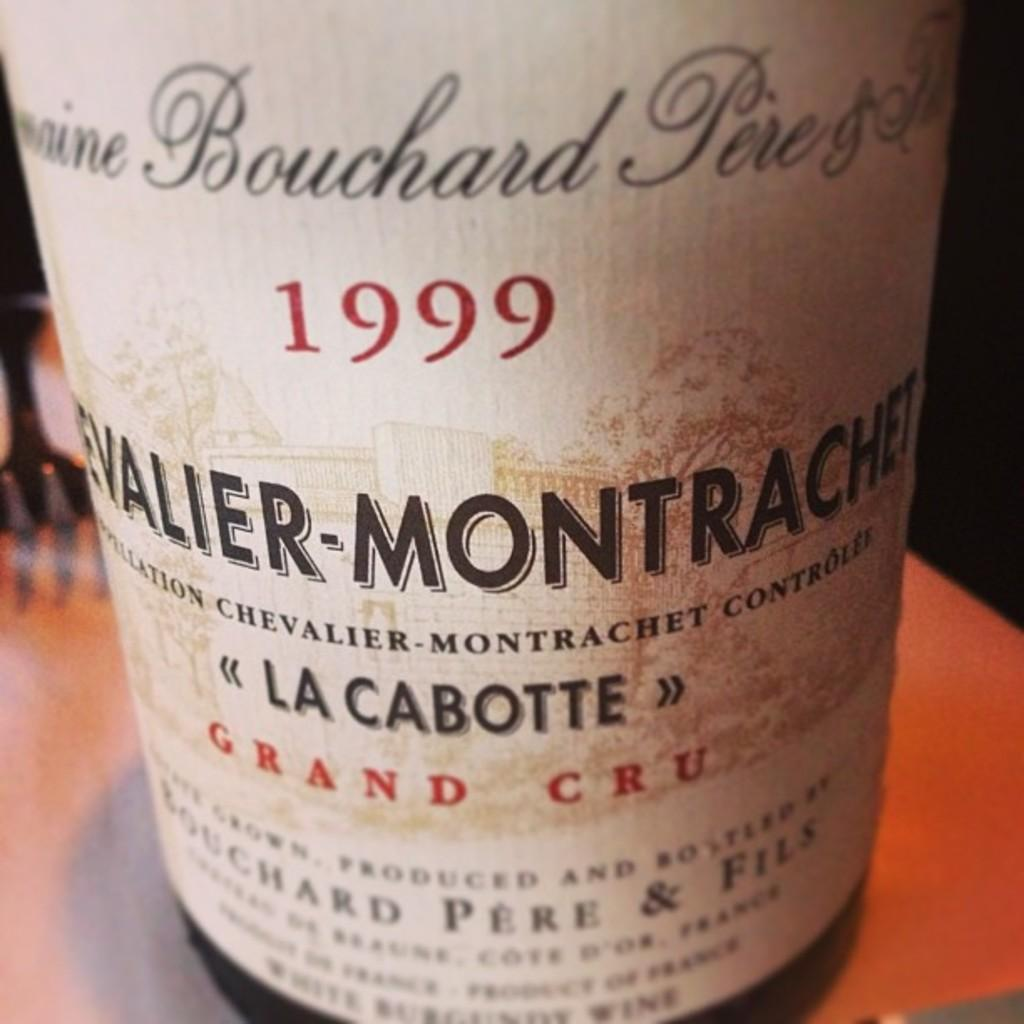<image>
Write a terse but informative summary of the picture. the words 1999 that is on a bottle of something 